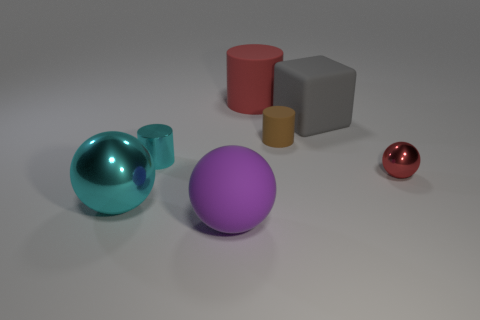There is a brown cylinder; is its size the same as the cylinder left of the red cylinder?
Your answer should be very brief. Yes. How many rubber things are gray blocks or tiny brown cylinders?
Offer a terse response. 2. How many other small things have the same shape as the tiny cyan shiny thing?
Your answer should be very brief. 1. There is a big object that is the same color as the small shiny ball; what is it made of?
Provide a succinct answer. Rubber. Is the size of the metallic sphere on the right side of the red rubber cylinder the same as the matte cylinder behind the brown cylinder?
Your answer should be very brief. No. There is a shiny object that is to the right of the purple ball; what shape is it?
Make the answer very short. Sphere. Is the number of tiny cyan metallic cylinders the same as the number of matte things?
Offer a terse response. No. There is a large object that is the same shape as the tiny brown matte object; what is it made of?
Your answer should be very brief. Rubber. Is the size of the metal ball on the right side of the brown rubber cylinder the same as the big gray matte thing?
Your response must be concise. No. How many tiny red shiny spheres are in front of the matte cube?
Your answer should be compact. 1. 